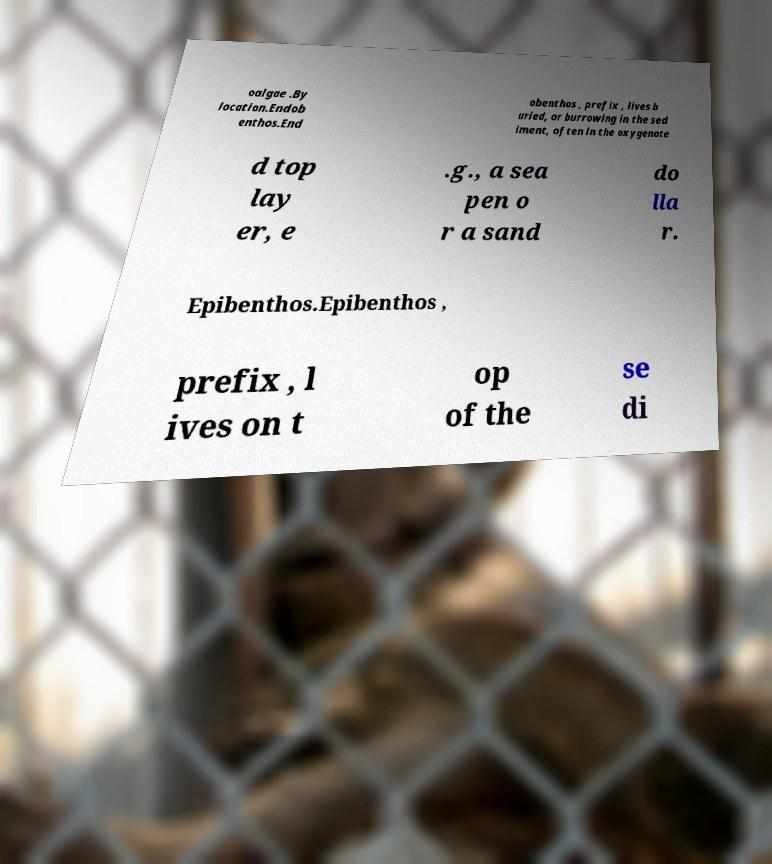Could you extract and type out the text from this image? oalgae .By location.Endob enthos.End obenthos , prefix , lives b uried, or burrowing in the sed iment, often in the oxygenate d top lay er, e .g., a sea pen o r a sand do lla r. Epibenthos.Epibenthos , prefix , l ives on t op of the se di 